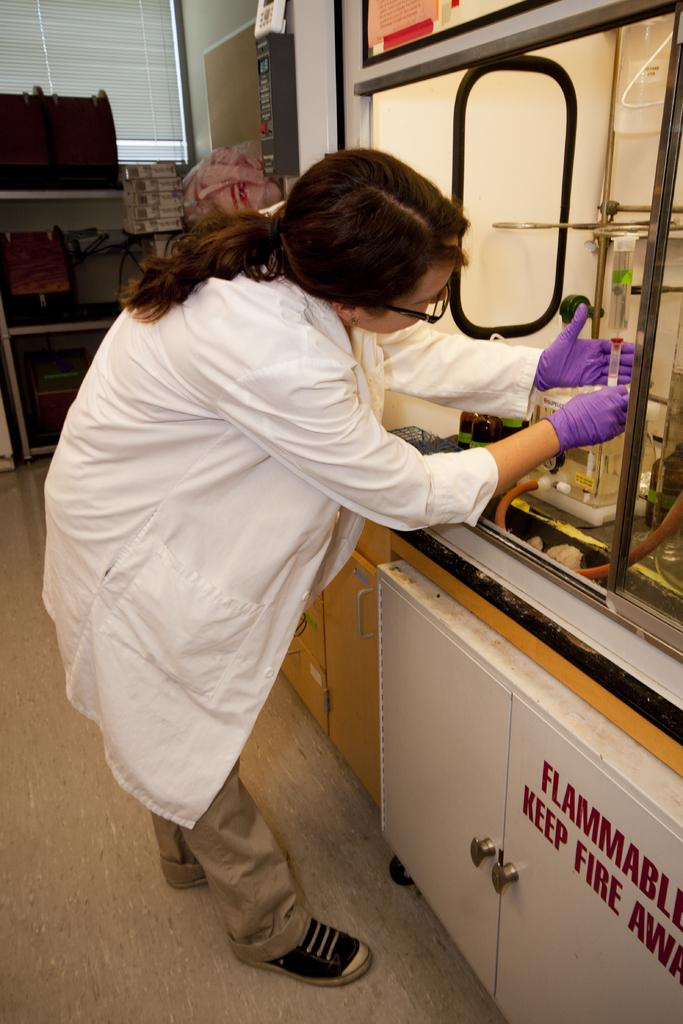Provide a one-sentence caption for the provided image. A female in a lab coat working near the sign that says "Flammable Keep Fire Away". 